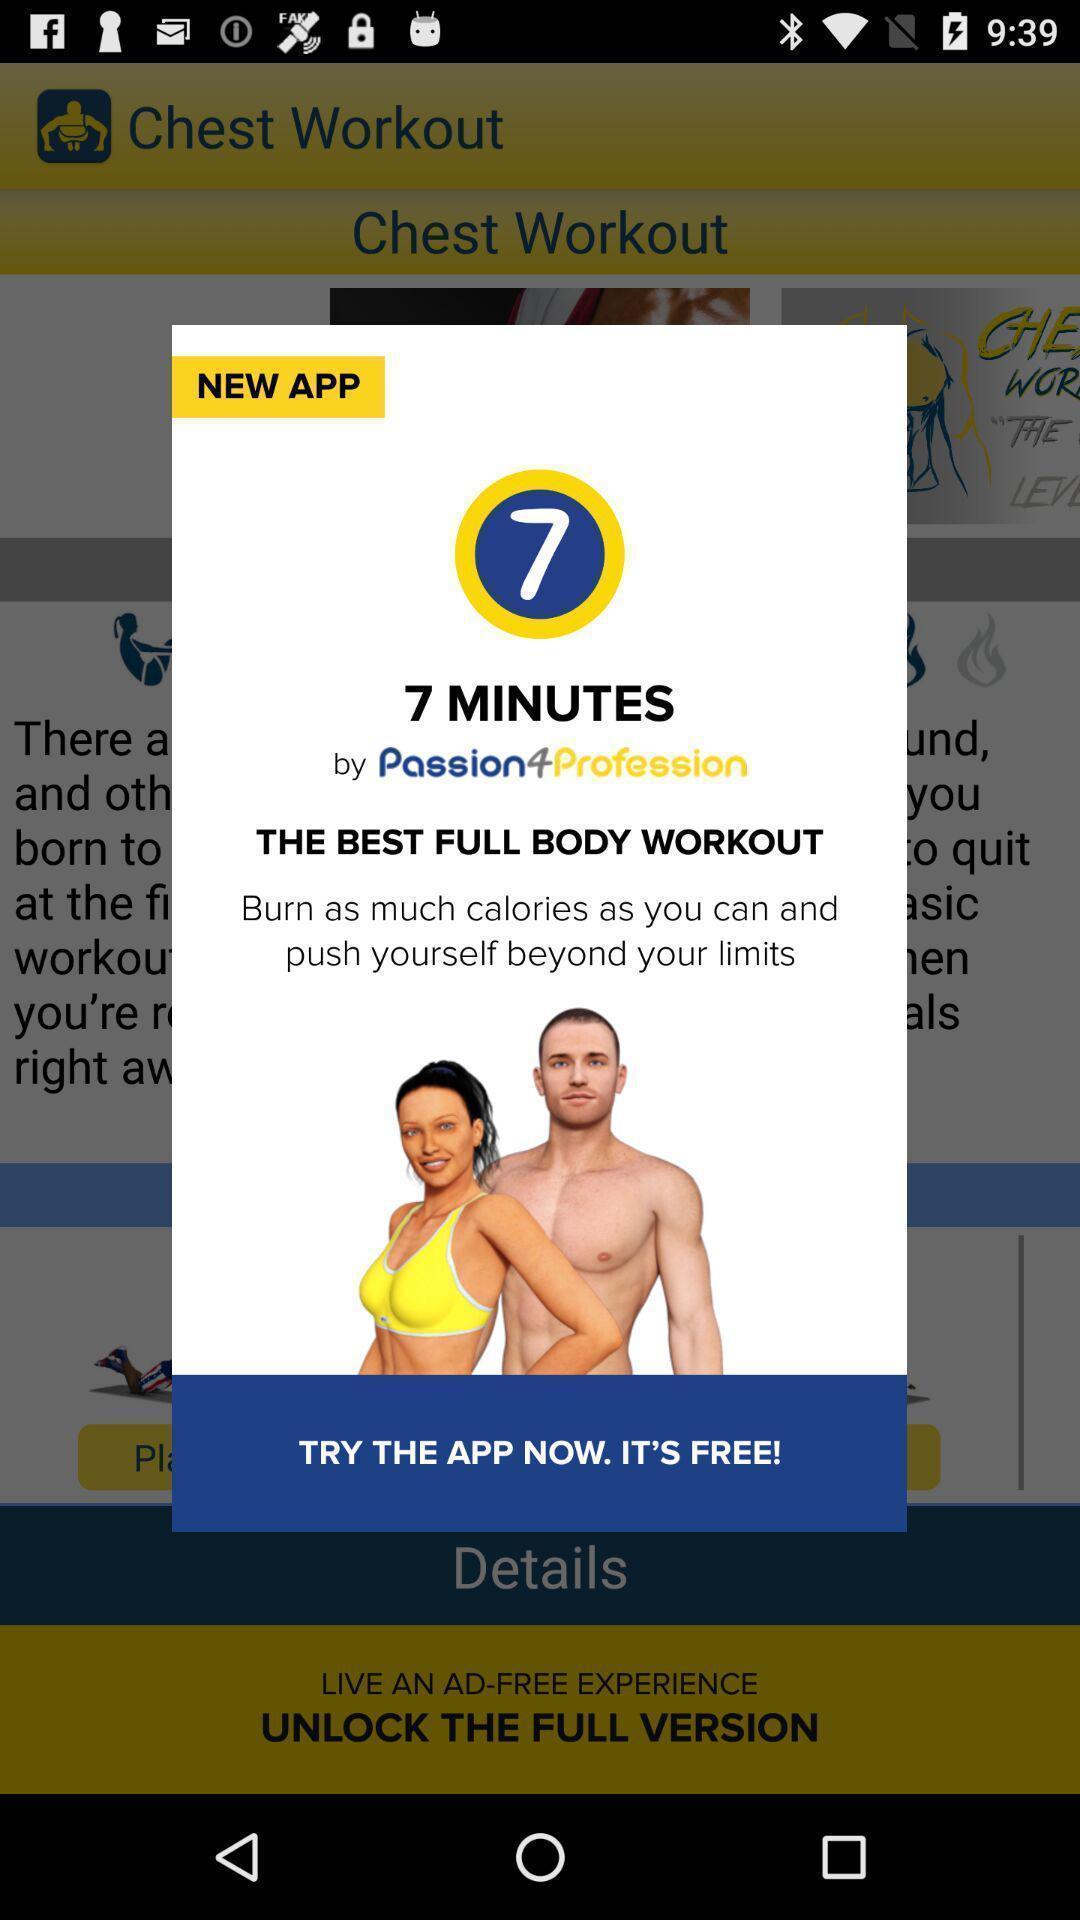Summarize the information in this screenshot. Popup displaying information about a workout application. 